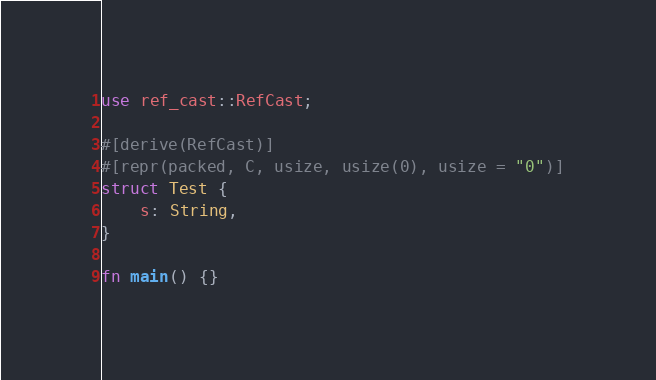Convert code to text. <code><loc_0><loc_0><loc_500><loc_500><_Rust_>use ref_cast::RefCast;

#[derive(RefCast)]
#[repr(packed, C, usize, usize(0), usize = "0")]
struct Test {
    s: String,
}

fn main() {}
</code> 